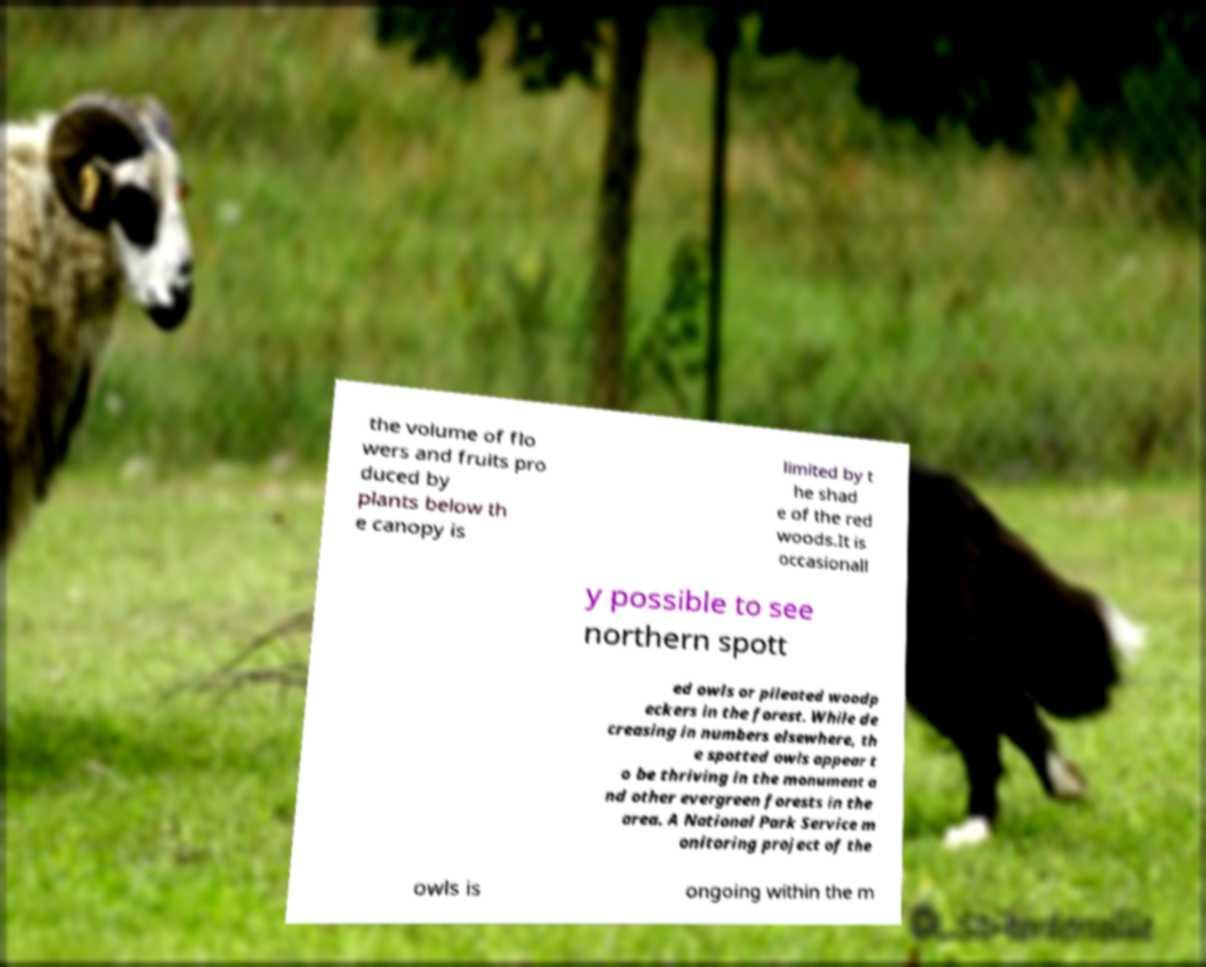Could you assist in decoding the text presented in this image and type it out clearly? the volume of flo wers and fruits pro duced by plants below th e canopy is limited by t he shad e of the red woods.It is occasionall y possible to see northern spott ed owls or pileated woodp eckers in the forest. While de creasing in numbers elsewhere, th e spotted owls appear t o be thriving in the monument a nd other evergreen forests in the area. A National Park Service m onitoring project of the owls is ongoing within the m 